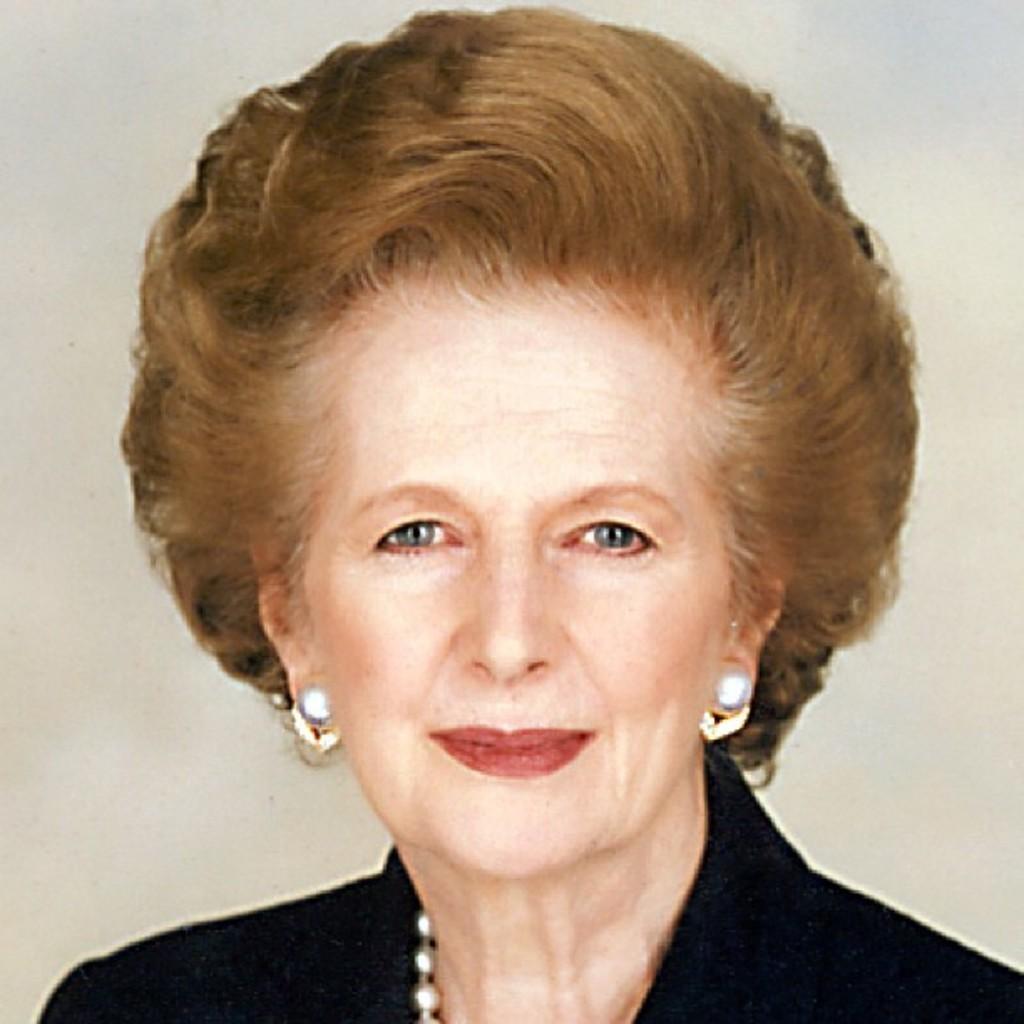Please provide a concise description of this image. In the foreground of this image, there is a woman in black dress and there is a cream background. 